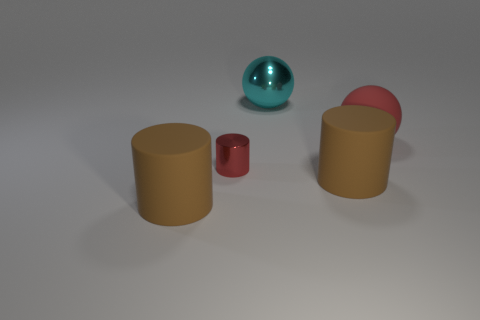There is a red sphere; does it have the same size as the brown rubber thing that is right of the metallic ball?
Keep it short and to the point. Yes. What is the color of the metal thing that is the same size as the red rubber thing?
Your answer should be very brief. Cyan. What size is the red matte sphere?
Give a very brief answer. Large. Does the cyan sphere that is behind the shiny cylinder have the same material as the small object?
Provide a succinct answer. Yes. Is the shape of the big cyan object the same as the red matte object?
Offer a terse response. Yes. There is a shiny object that is behind the red object that is on the left side of the ball that is in front of the big cyan object; what is its shape?
Ensure brevity in your answer.  Sphere. There is a metallic object that is to the left of the cyan object; does it have the same shape as the large object that is behind the rubber sphere?
Offer a very short reply. No. Is there a large brown cylinder made of the same material as the big red thing?
Your response must be concise. Yes. The large matte ball that is to the right of the big brown matte cylinder right of the metal thing behind the red metal thing is what color?
Keep it short and to the point. Red. Is the material of the large ball that is to the right of the cyan shiny thing the same as the brown cylinder to the right of the cyan metal thing?
Keep it short and to the point. Yes. 